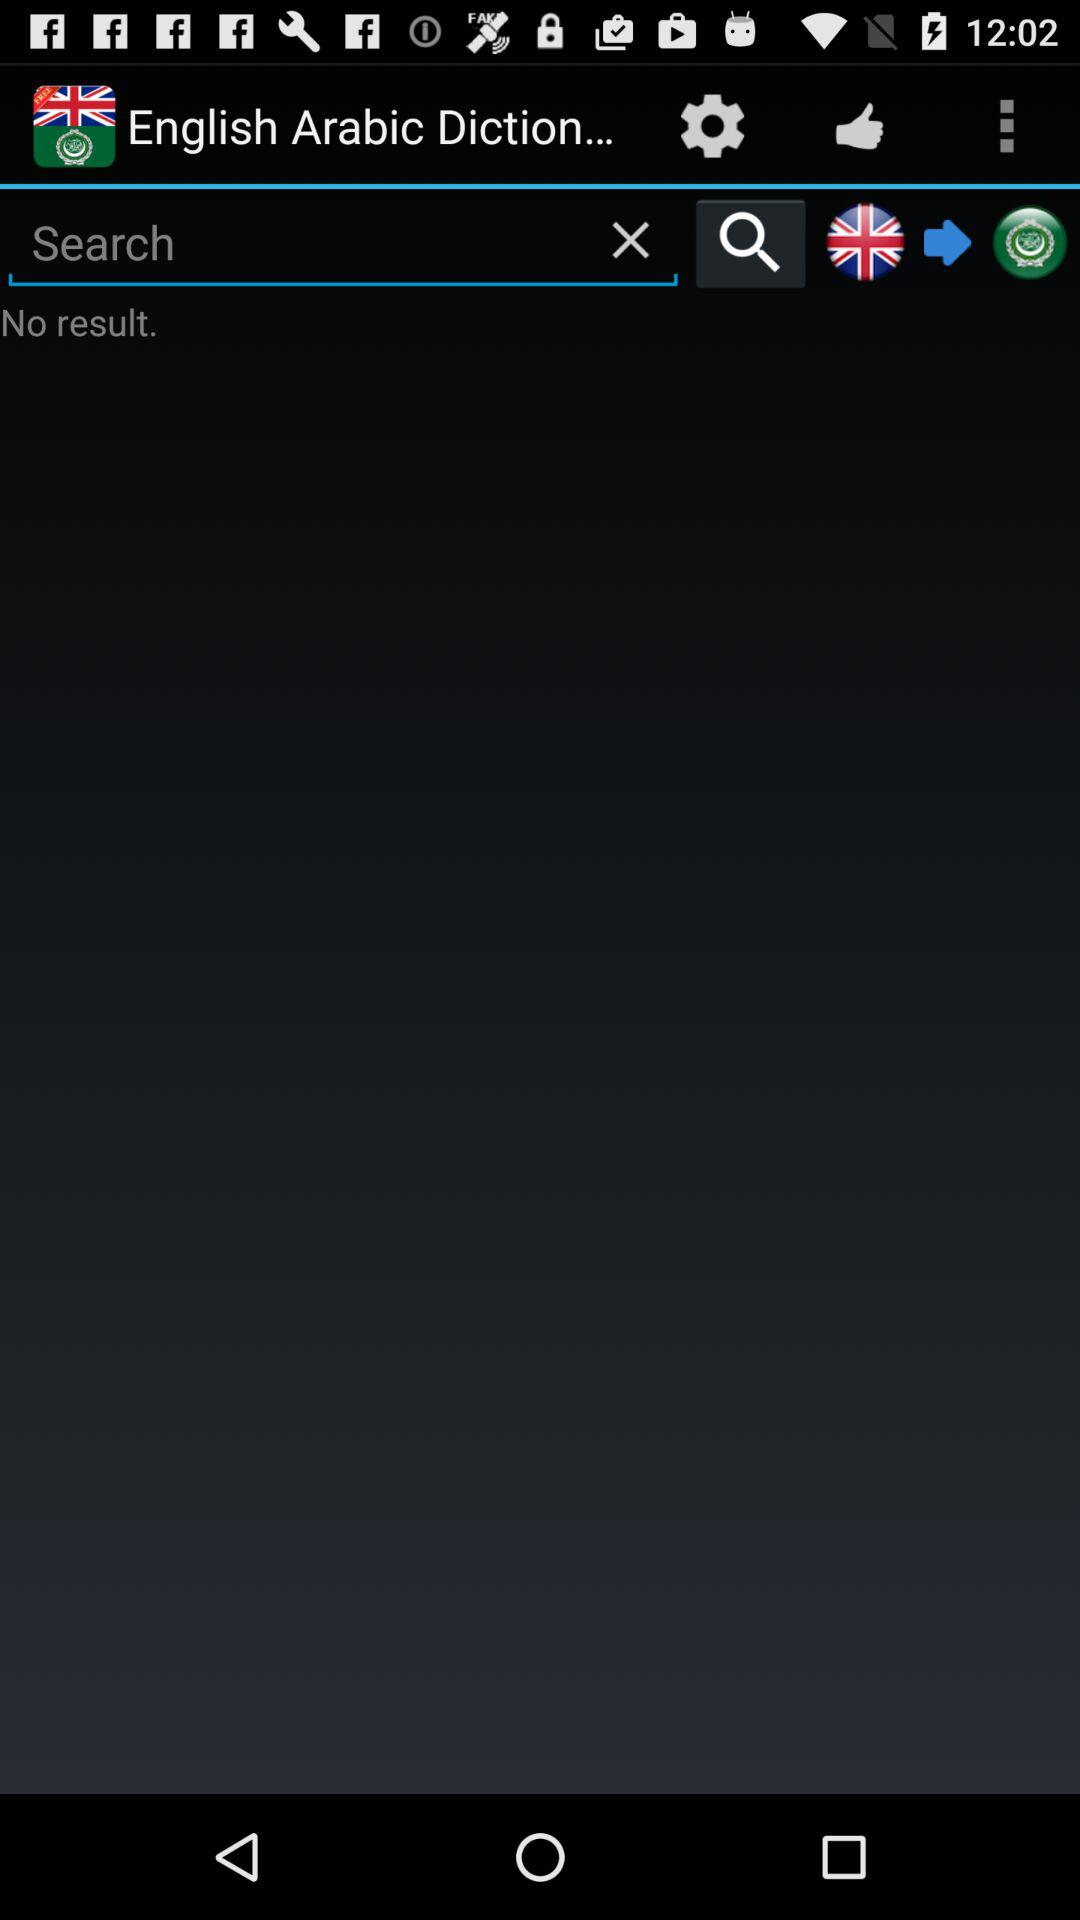What is the name of the application? The application name is "English Arabic Diction...". 